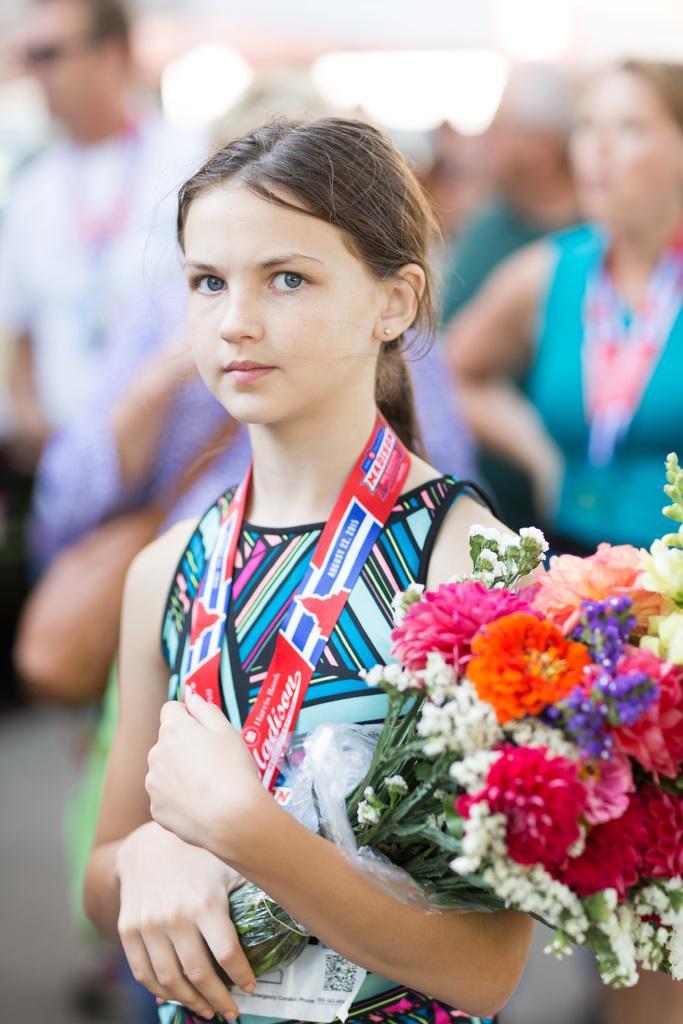In one or two sentences, can you explain what this image depicts? In this image I can see a girl is standing and I can see she is holding a flower bouquet. I can also see she is wearing a red colour thing around her neck. In the background I can see few more people and I can see this image is little bit blurry from background. 